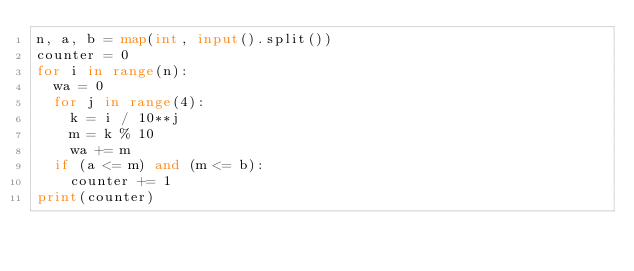<code> <loc_0><loc_0><loc_500><loc_500><_Python_>n, a, b = map(int, input().split())
counter = 0
for i in range(n):
  wa = 0
  for j in range(4):
    k = i / 10**j
    m = k % 10
    wa += m
  if (a <= m) and (m <= b):
    counter += 1
print(counter)</code> 